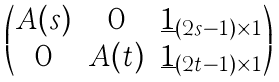Convert formula to latex. <formula><loc_0><loc_0><loc_500><loc_500>\begin{pmatrix} A ( s ) & 0 & \underline { 1 } _ { ( 2 s - 1 ) \times 1 } \\ 0 & A ( t ) & \underline { 1 } _ { ( 2 t - 1 ) \times 1 } \end{pmatrix}</formula> 